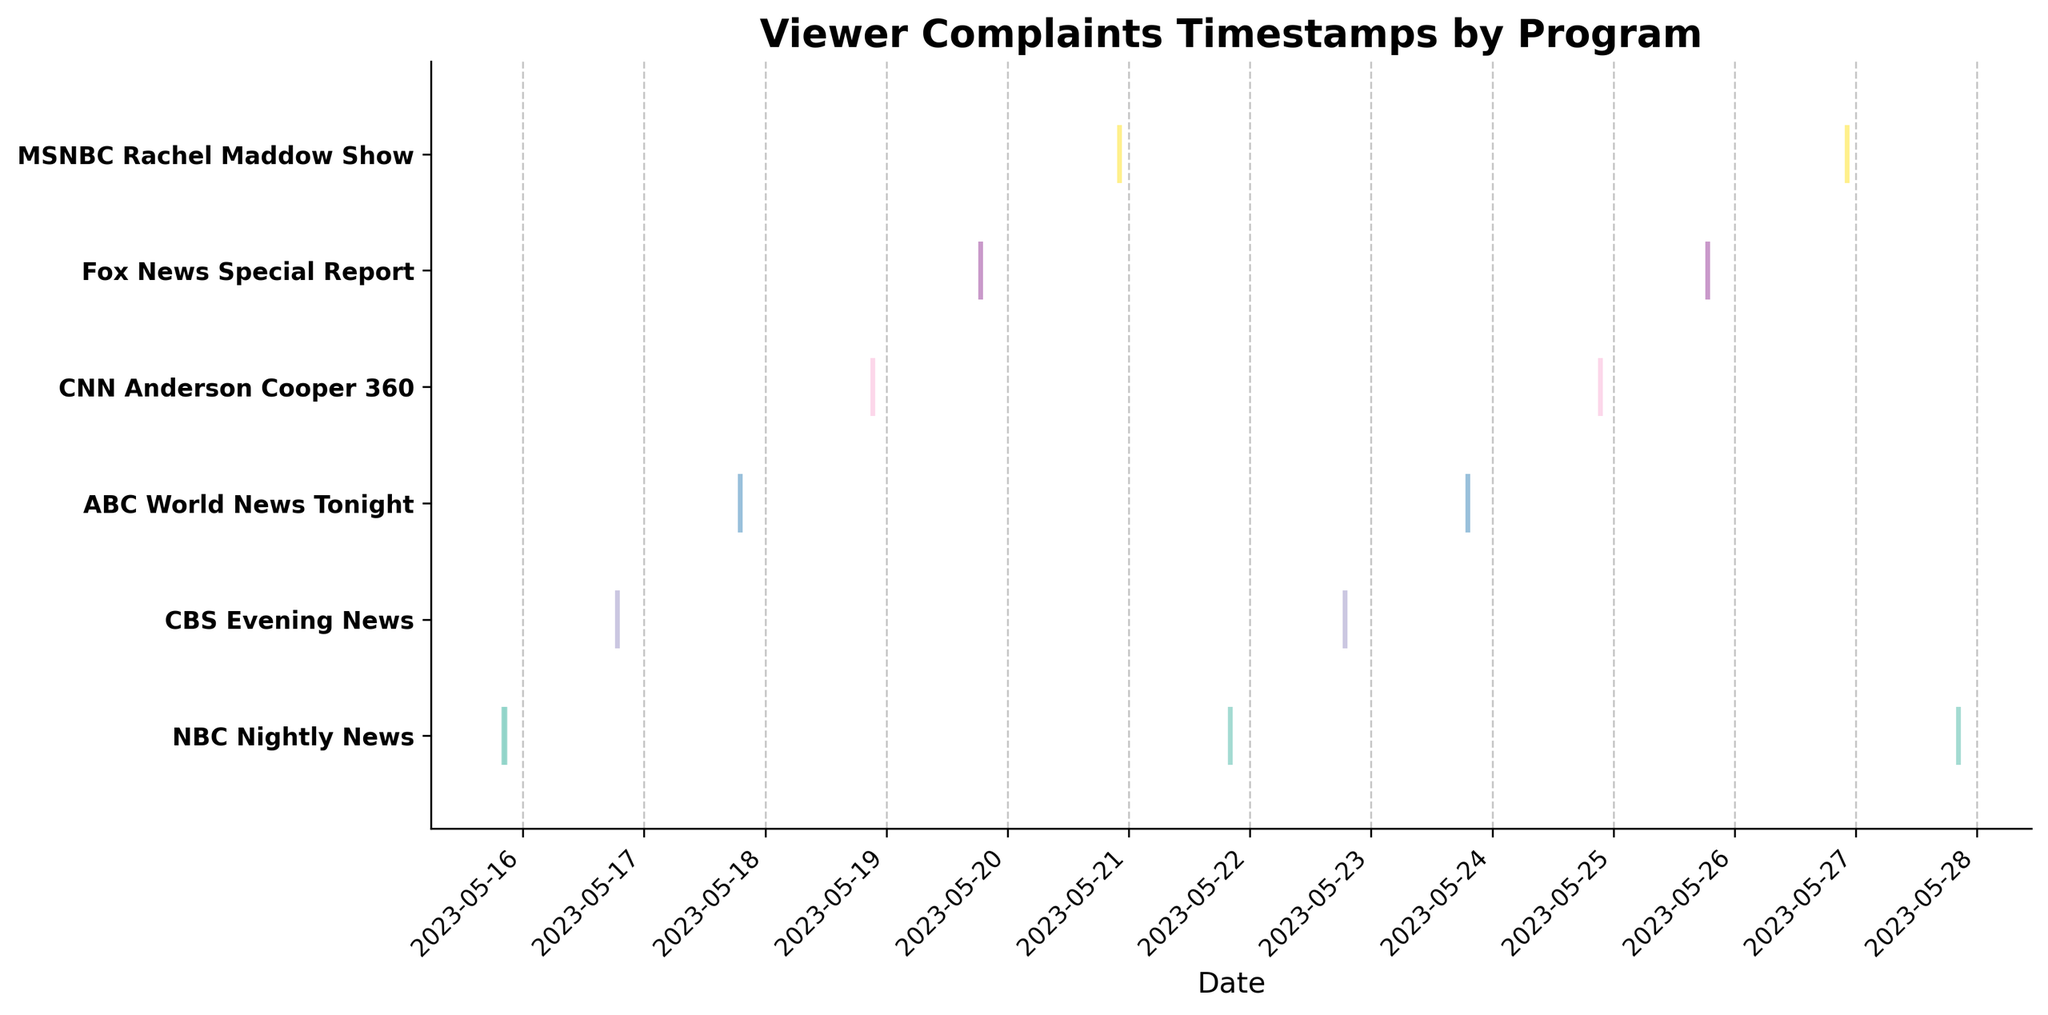What's the title of the plot? The title of the plot is written at the top in bold letters. It reads "Viewer Complaints Timestamps by Program".
Answer: Viewer Complaints Timestamps by Program How many programs are displayed in the plot? The number of programs can be counted along the y-axis, where each unique program is listed. There are 7 programs displayed.
Answer: 7 Which program had the highest number of complaints? By counting the number of event lines (timestamps) for each program, NBC Nightly News has the highest number with 4 complaints.
Answer: NBC Nightly News Which program received a complaint closest to mid-May 2023? The complaint for NBC Nightly News on May 15, 2023, seen at the bottom of the x-axis, is closest to the middle of May.
Answer: NBC Nightly News On which date did the Fox News Special Report receive complaints? The event lines for this program are aligned with the dates on the x-axis. The complaints occurred on May 19 and May 25, 2023.
Answer: May 19 and May 25, 2023 What's the average interval between complaints for NBC Nightly News? The timestamps for NBC Nightly News are May 15, 21, 27, and another on May 15. The intervals are 6 days (May 15 to May 21), 6 days (May 21 to May 27). Average is (6 + 6) / 2 = 6 days.
Answer: 6 days Which program had all its complaints consistently happening after 8 PM? By examining the position of event lines relative to the time in the day (20:00 onwards), the MSNBC Rachel Maddow Show had complaints consistently around 10 PM.
Answer: MSNBC Rachel Maddow Show How many programs received complaints on May 15, 2023? Counting the event lines on May 15 along the x-axis, only NBC Nightly News received complaints on that date.
Answer: 1 Is there any program that received complaints on consecutive days? The complaints on CBS Evening News on May 16 and May 22, along the x-axis, are not on consecutive days, indicating no program fits this criterion.
Answer: No Which program had the least number of complaints? By counting the number of event lines for each program, CBS Evening News, ABC World News Tonight, and CNN Anderson Cooper 360 have 2 complaints each.
Answer: CBS Evening News, ABC World News Tonight, and CNN Anderson Cooper 360 